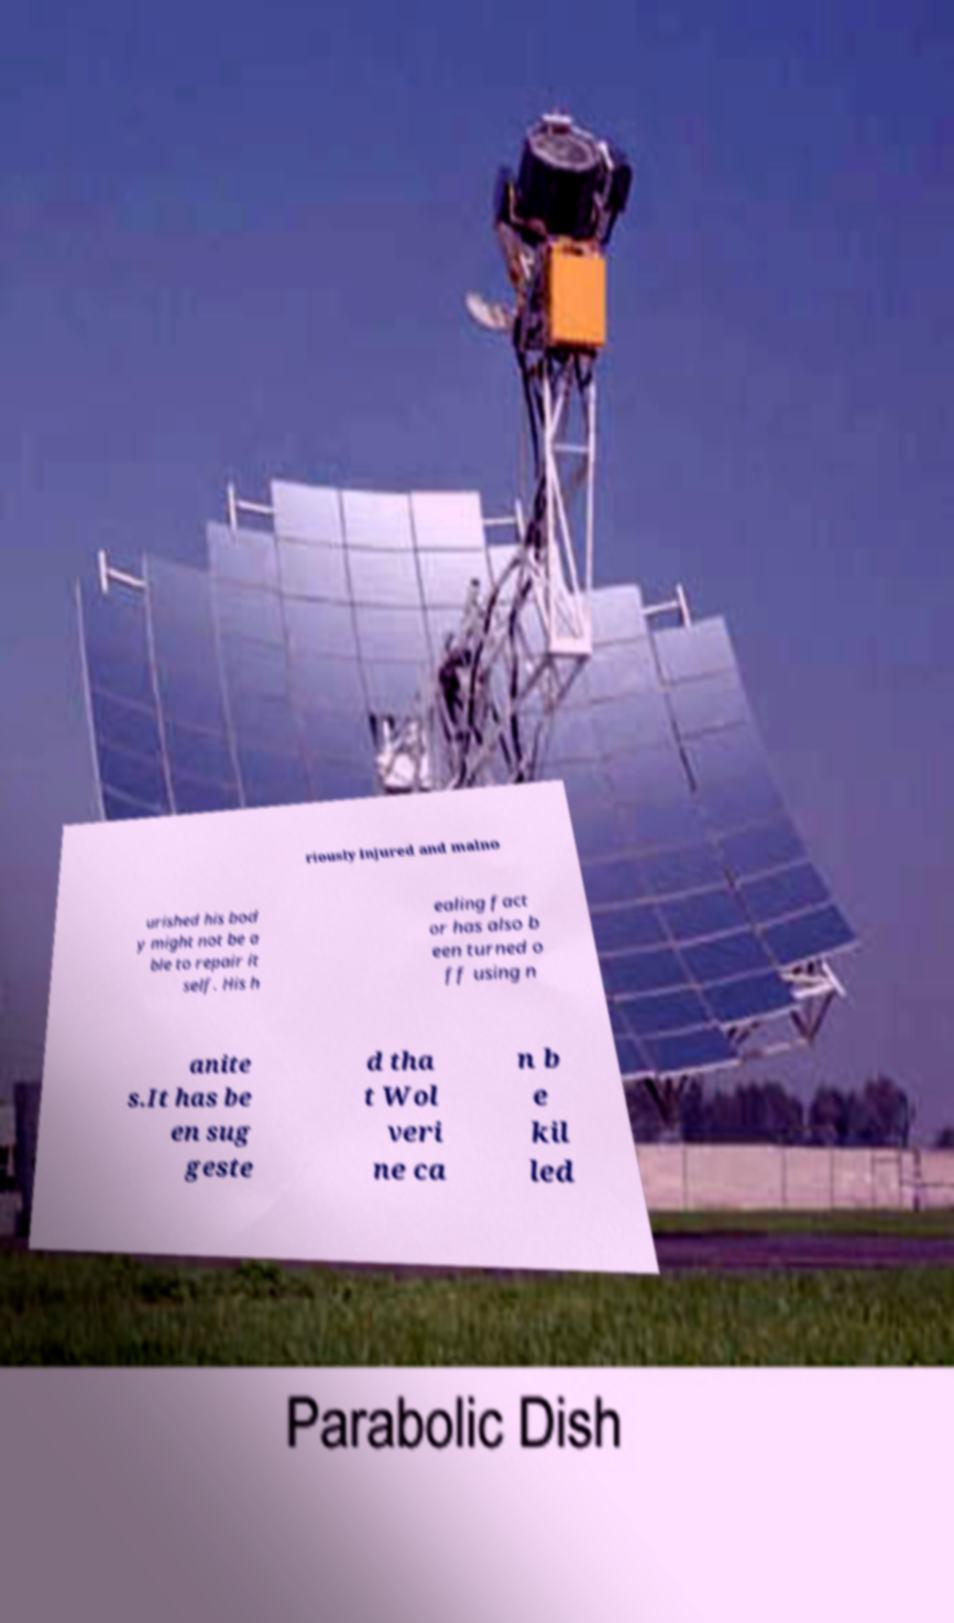Could you assist in decoding the text presented in this image and type it out clearly? riously injured and malno urished his bod y might not be a ble to repair it self. His h ealing fact or has also b een turned o ff using n anite s.It has be en sug geste d tha t Wol veri ne ca n b e kil led 